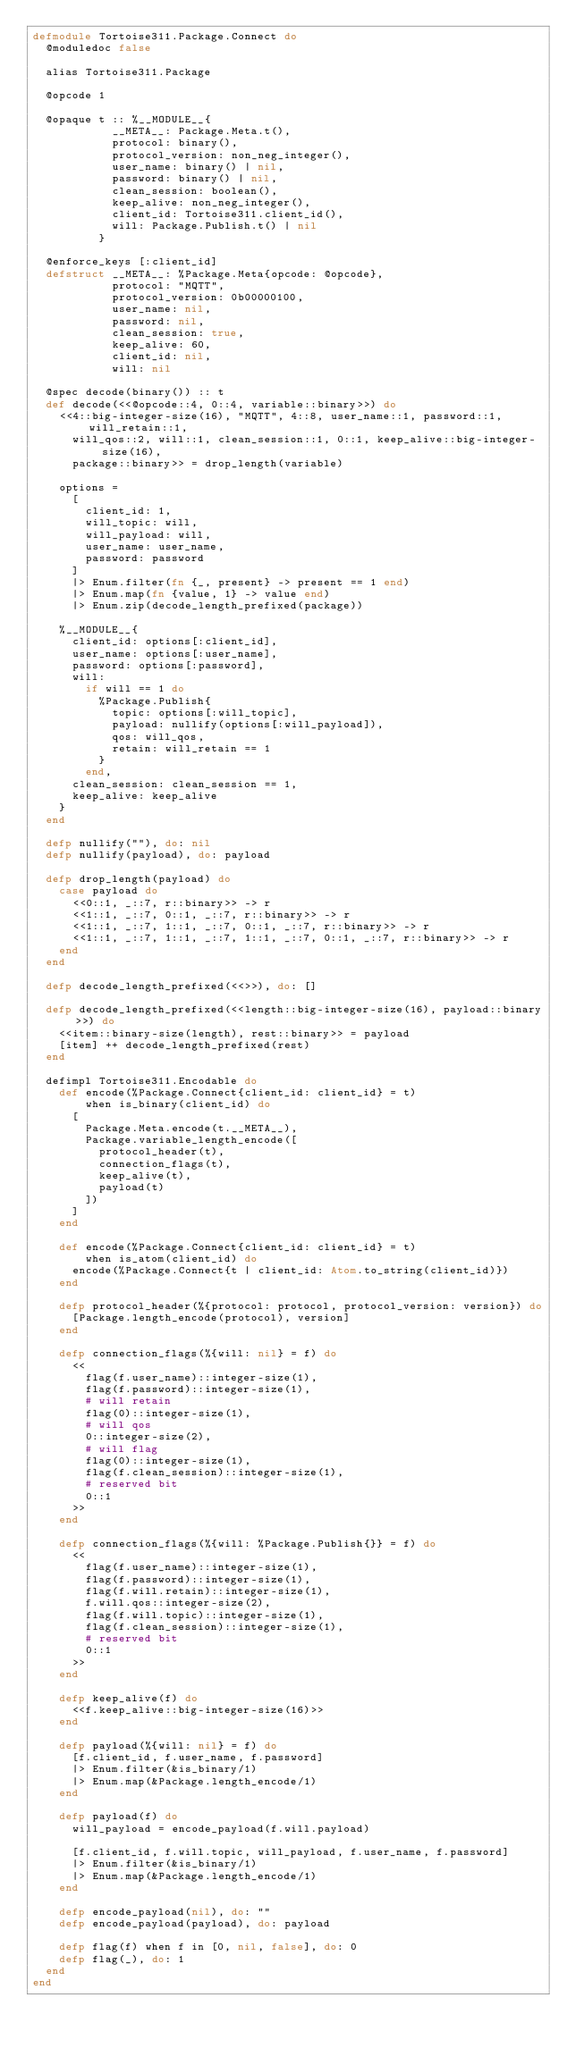Convert code to text. <code><loc_0><loc_0><loc_500><loc_500><_Elixir_>defmodule Tortoise311.Package.Connect do
  @moduledoc false

  alias Tortoise311.Package

  @opcode 1

  @opaque t :: %__MODULE__{
            __META__: Package.Meta.t(),
            protocol: binary(),
            protocol_version: non_neg_integer(),
            user_name: binary() | nil,
            password: binary() | nil,
            clean_session: boolean(),
            keep_alive: non_neg_integer(),
            client_id: Tortoise311.client_id(),
            will: Package.Publish.t() | nil
          }

  @enforce_keys [:client_id]
  defstruct __META__: %Package.Meta{opcode: @opcode},
            protocol: "MQTT",
            protocol_version: 0b00000100,
            user_name: nil,
            password: nil,
            clean_session: true,
            keep_alive: 60,
            client_id: nil,
            will: nil

  @spec decode(binary()) :: t
  def decode(<<@opcode::4, 0::4, variable::binary>>) do
    <<4::big-integer-size(16), "MQTT", 4::8, user_name::1, password::1, will_retain::1,
      will_qos::2, will::1, clean_session::1, 0::1, keep_alive::big-integer-size(16),
      package::binary>> = drop_length(variable)

    options =
      [
        client_id: 1,
        will_topic: will,
        will_payload: will,
        user_name: user_name,
        password: password
      ]
      |> Enum.filter(fn {_, present} -> present == 1 end)
      |> Enum.map(fn {value, 1} -> value end)
      |> Enum.zip(decode_length_prefixed(package))

    %__MODULE__{
      client_id: options[:client_id],
      user_name: options[:user_name],
      password: options[:password],
      will:
        if will == 1 do
          %Package.Publish{
            topic: options[:will_topic],
            payload: nullify(options[:will_payload]),
            qos: will_qos,
            retain: will_retain == 1
          }
        end,
      clean_session: clean_session == 1,
      keep_alive: keep_alive
    }
  end

  defp nullify(""), do: nil
  defp nullify(payload), do: payload

  defp drop_length(payload) do
    case payload do
      <<0::1, _::7, r::binary>> -> r
      <<1::1, _::7, 0::1, _::7, r::binary>> -> r
      <<1::1, _::7, 1::1, _::7, 0::1, _::7, r::binary>> -> r
      <<1::1, _::7, 1::1, _::7, 1::1, _::7, 0::1, _::7, r::binary>> -> r
    end
  end

  defp decode_length_prefixed(<<>>), do: []

  defp decode_length_prefixed(<<length::big-integer-size(16), payload::binary>>) do
    <<item::binary-size(length), rest::binary>> = payload
    [item] ++ decode_length_prefixed(rest)
  end

  defimpl Tortoise311.Encodable do
    def encode(%Package.Connect{client_id: client_id} = t)
        when is_binary(client_id) do
      [
        Package.Meta.encode(t.__META__),
        Package.variable_length_encode([
          protocol_header(t),
          connection_flags(t),
          keep_alive(t),
          payload(t)
        ])
      ]
    end

    def encode(%Package.Connect{client_id: client_id} = t)
        when is_atom(client_id) do
      encode(%Package.Connect{t | client_id: Atom.to_string(client_id)})
    end

    defp protocol_header(%{protocol: protocol, protocol_version: version}) do
      [Package.length_encode(protocol), version]
    end

    defp connection_flags(%{will: nil} = f) do
      <<
        flag(f.user_name)::integer-size(1),
        flag(f.password)::integer-size(1),
        # will retain
        flag(0)::integer-size(1),
        # will qos
        0::integer-size(2),
        # will flag
        flag(0)::integer-size(1),
        flag(f.clean_session)::integer-size(1),
        # reserved bit
        0::1
      >>
    end

    defp connection_flags(%{will: %Package.Publish{}} = f) do
      <<
        flag(f.user_name)::integer-size(1),
        flag(f.password)::integer-size(1),
        flag(f.will.retain)::integer-size(1),
        f.will.qos::integer-size(2),
        flag(f.will.topic)::integer-size(1),
        flag(f.clean_session)::integer-size(1),
        # reserved bit
        0::1
      >>
    end

    defp keep_alive(f) do
      <<f.keep_alive::big-integer-size(16)>>
    end

    defp payload(%{will: nil} = f) do
      [f.client_id, f.user_name, f.password]
      |> Enum.filter(&is_binary/1)
      |> Enum.map(&Package.length_encode/1)
    end

    defp payload(f) do
      will_payload = encode_payload(f.will.payload)

      [f.client_id, f.will.topic, will_payload, f.user_name, f.password]
      |> Enum.filter(&is_binary/1)
      |> Enum.map(&Package.length_encode/1)
    end

    defp encode_payload(nil), do: ""
    defp encode_payload(payload), do: payload

    defp flag(f) when f in [0, nil, false], do: 0
    defp flag(_), do: 1
  end
end
</code> 